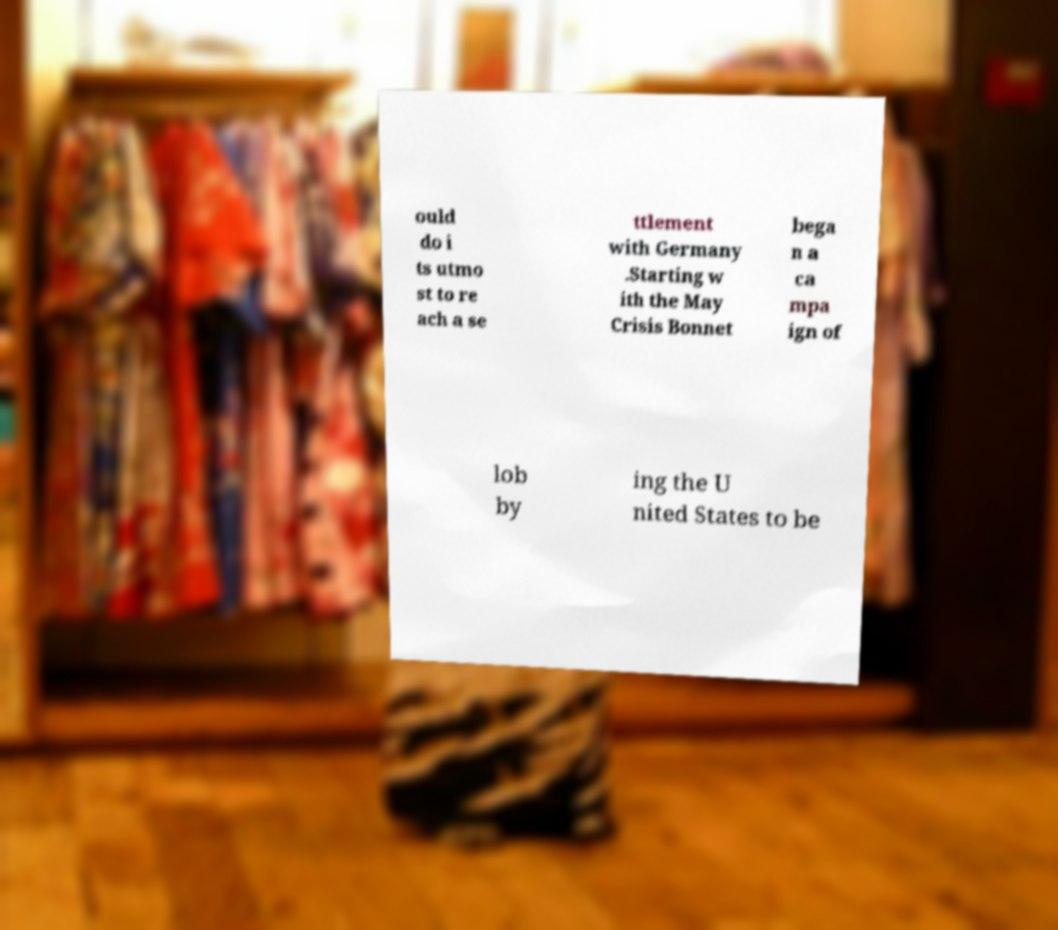What messages or text are displayed in this image? I need them in a readable, typed format. ould do i ts utmo st to re ach a se ttlement with Germany .Starting w ith the May Crisis Bonnet bega n a ca mpa ign of lob by ing the U nited States to be 